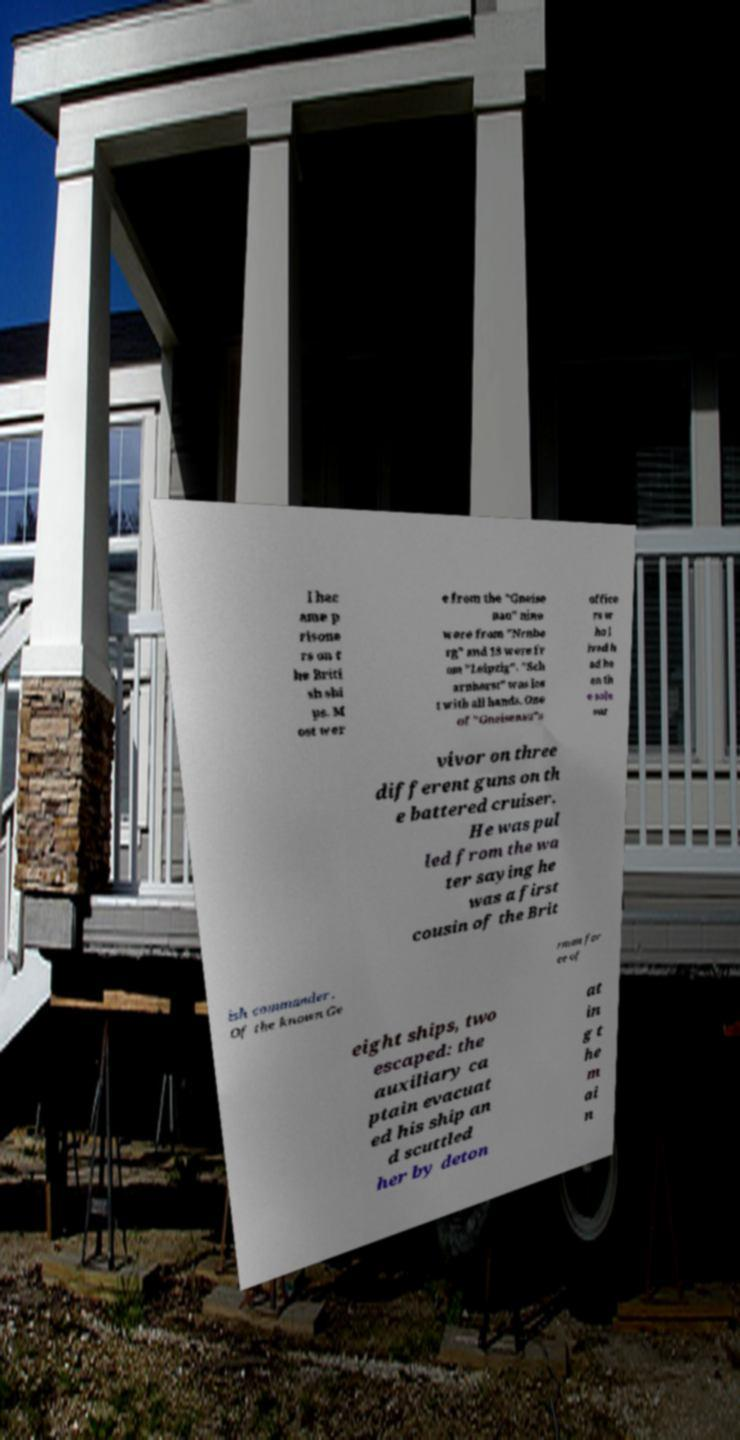Could you assist in decoding the text presented in this image and type it out clearly? l bec ame p risone rs on t he Briti sh shi ps. M ost wer e from the "Gneise nau" nine were from "Nrnbe rg" and 18 were fr om "Leipzig". "Sch arnhorst" was los t with all hands. One of "Gneisenau"s office rs w ho l ived h ad be en th e sole sur vivor on three different guns on th e battered cruiser. He was pul led from the wa ter saying he was a first cousin of the Brit ish commander . Of the known Ge rman for ce of eight ships, two escaped: the auxiliary ca ptain evacuat ed his ship an d scuttled her by deton at in g t he m ai n 